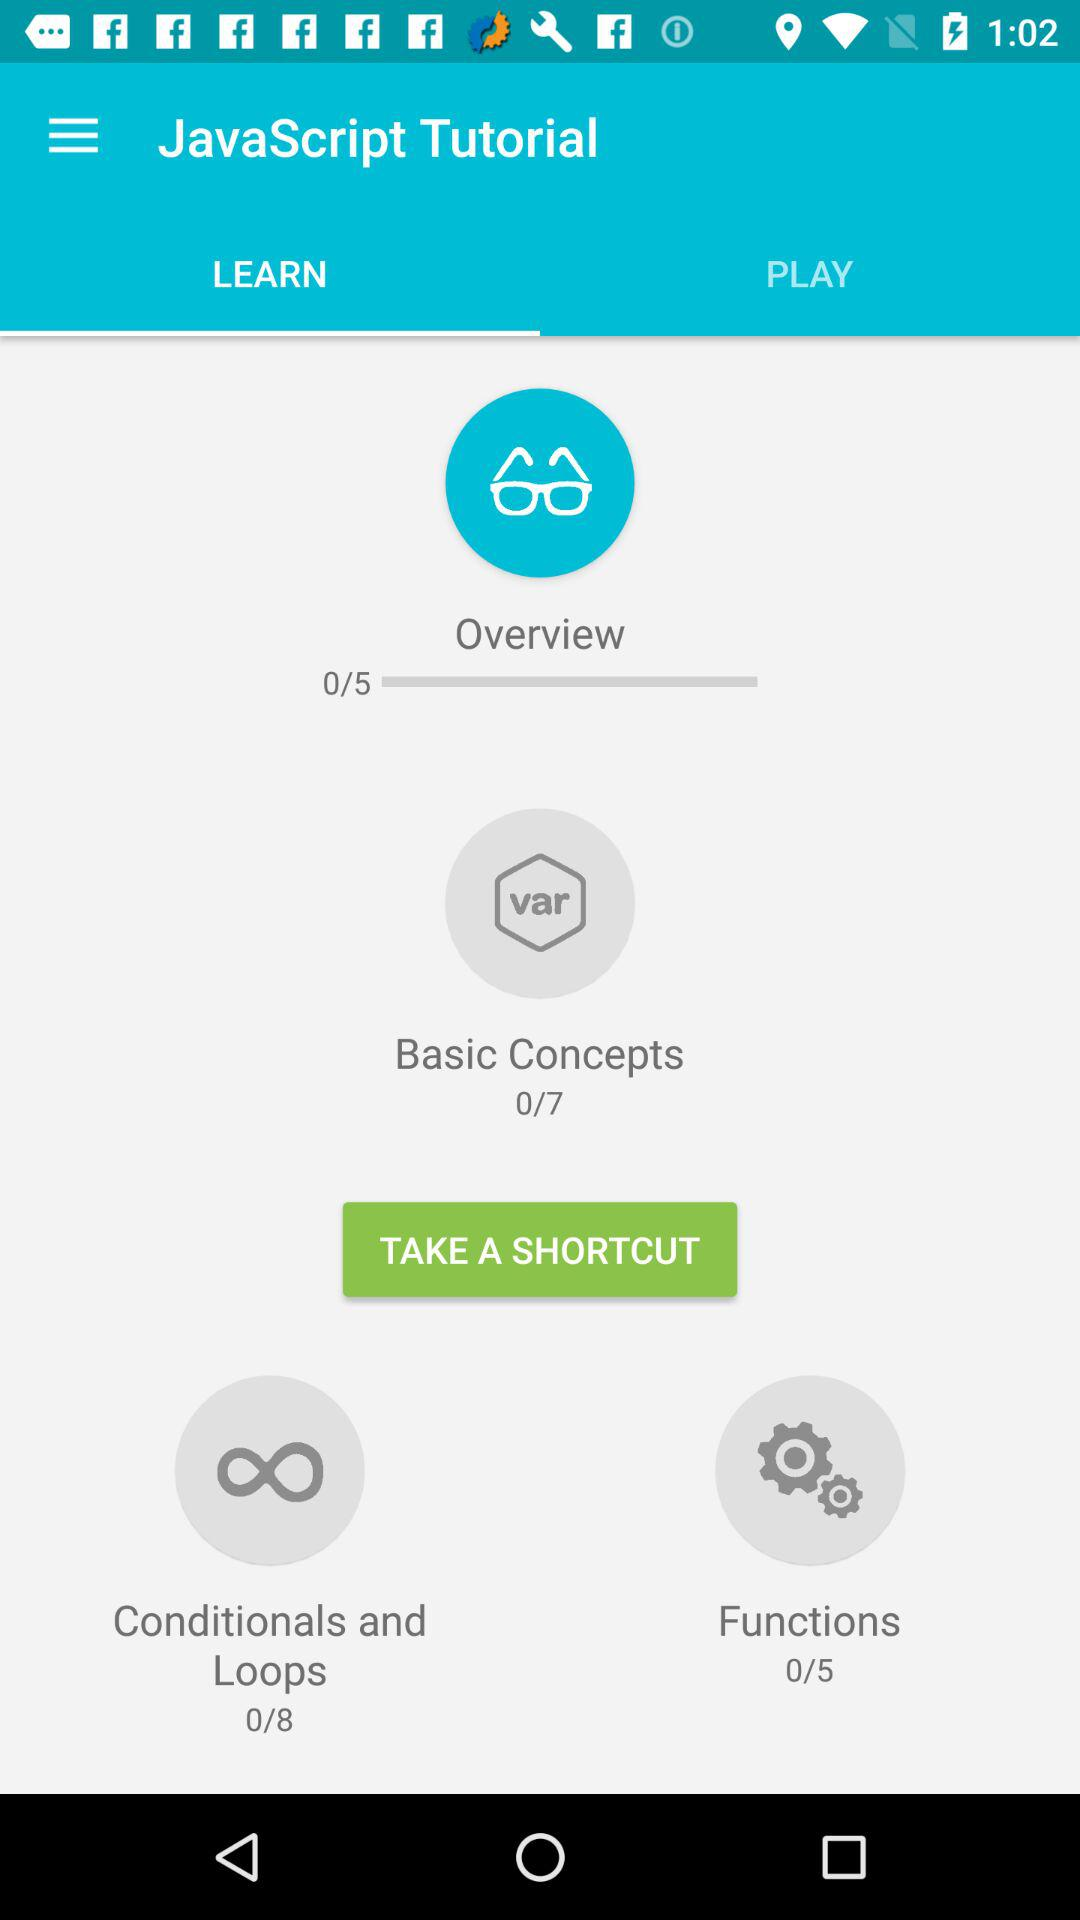How many modules are there for the "Overview" topic? There are 5 modules. 